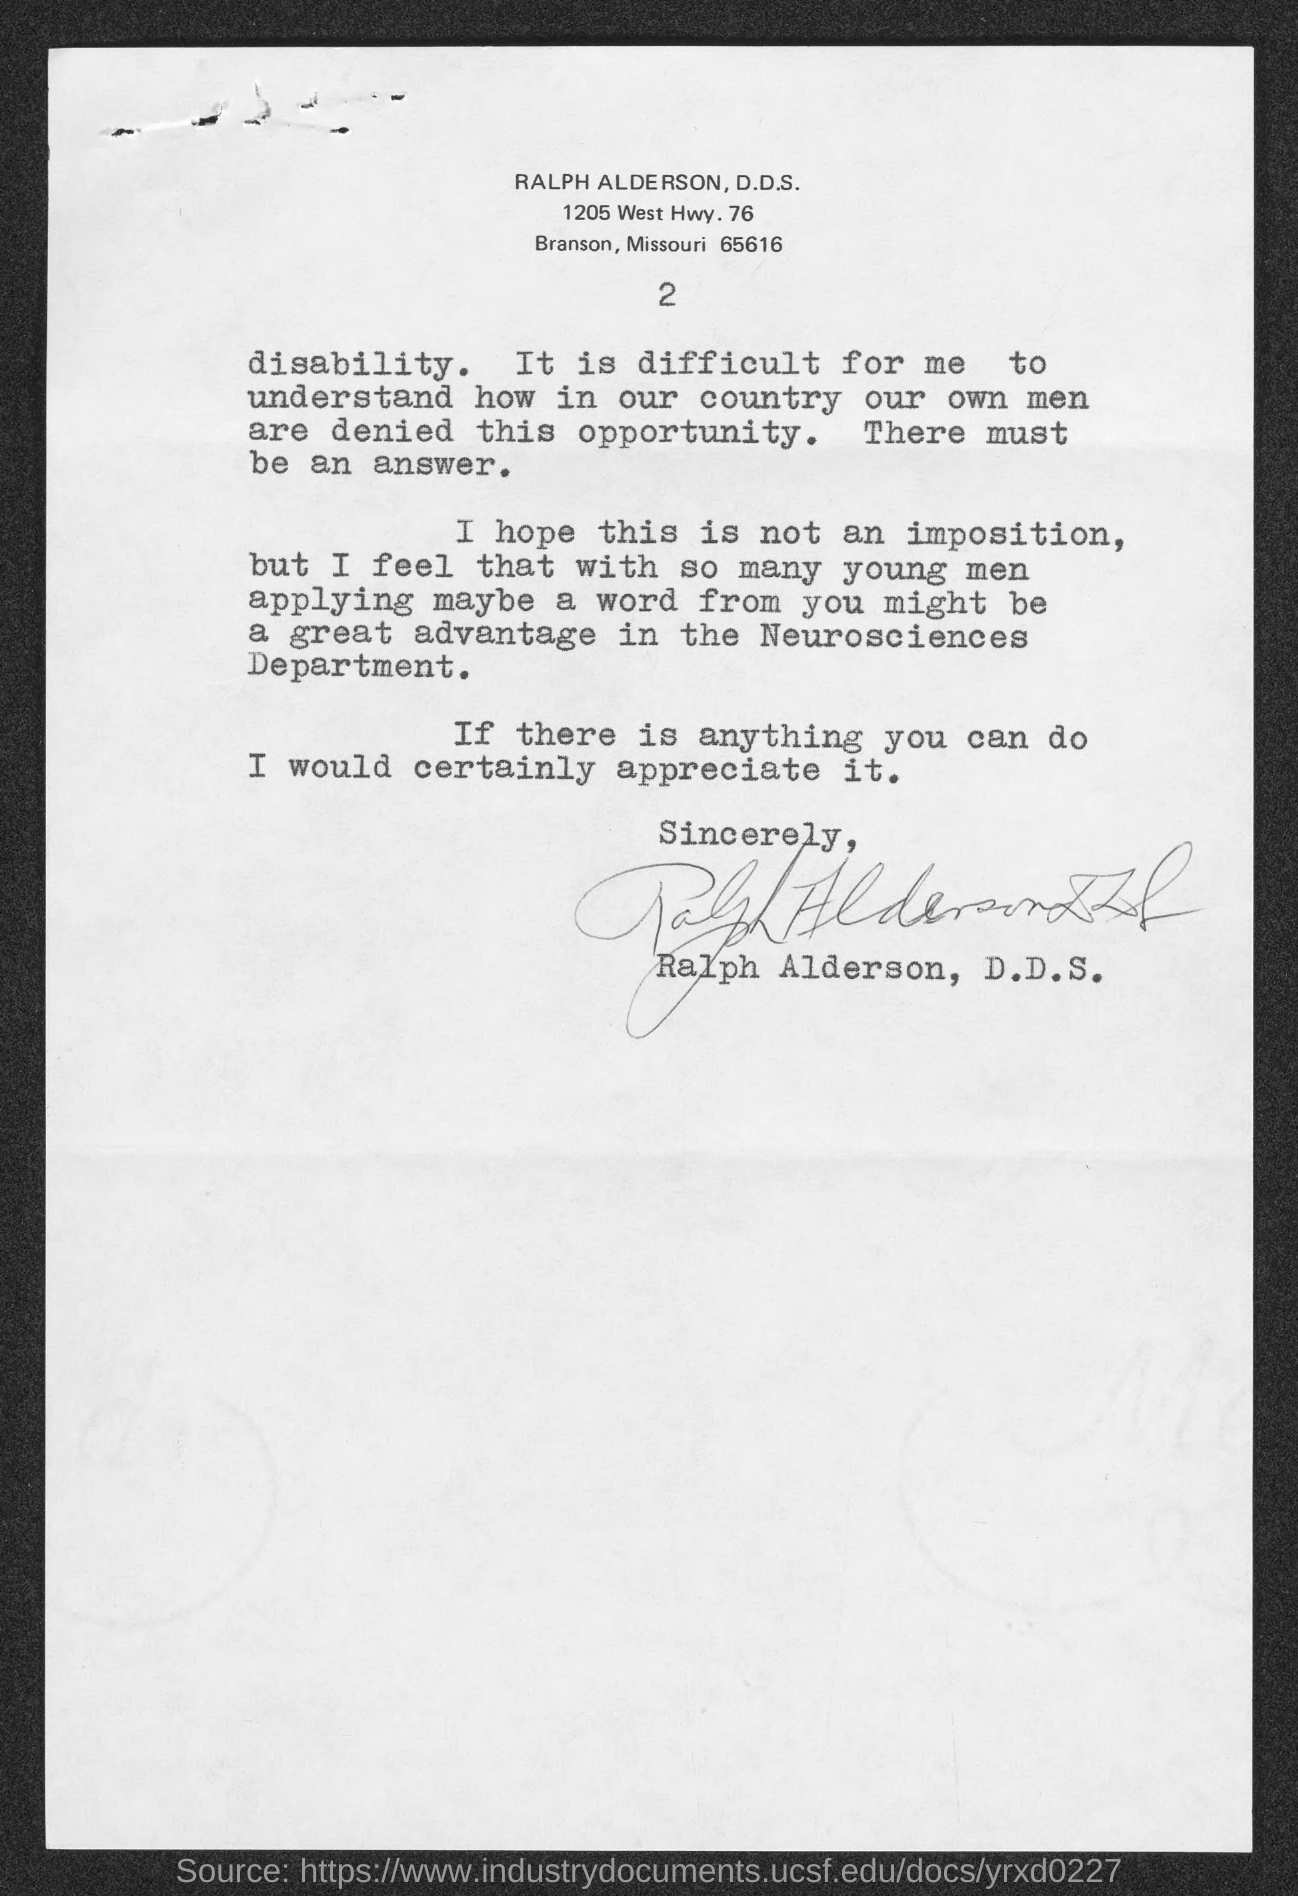What is the page number ?
Your answer should be very brief. 2. 